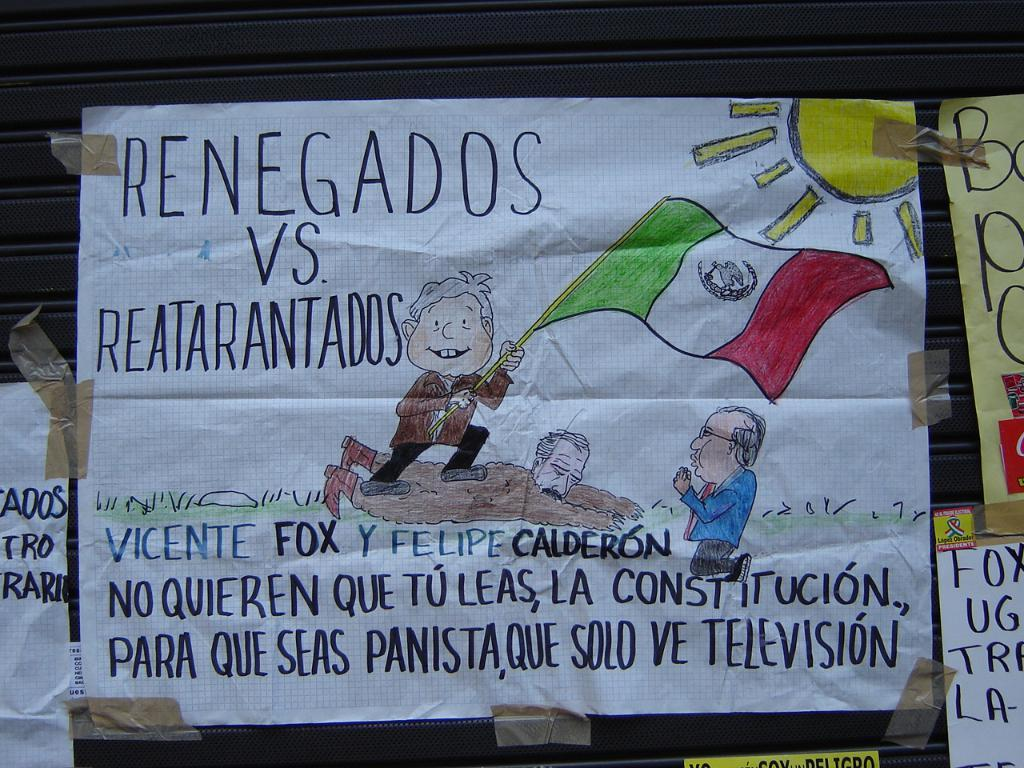<image>
Relay a brief, clear account of the picture shown. A sign that says RENEGADOS VS. REATARANTADOS with a drawn picture. 